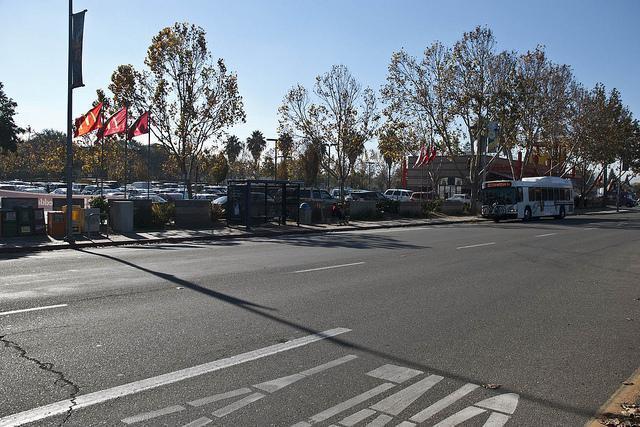How many people are not sitting?
Give a very brief answer. 0. 